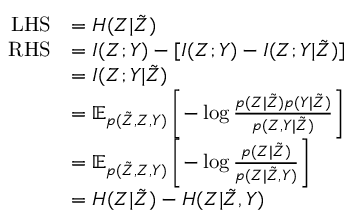<formula> <loc_0><loc_0><loc_500><loc_500>\begin{array} { r l } { L H S } & { = H ( Z | \tilde { Z } ) } \\ { R H S } & { = I ( Z ; Y ) - [ I ( Z ; Y ) - I ( Z ; Y | \tilde { Z } ) ] } \\ & { = I ( Z ; Y | \tilde { Z } ) } \\ & { = \mathbb { E } _ { p ( \tilde { Z } , Z , Y ) } \left [ - \log \frac { p ( Z | \tilde { Z } ) p ( Y | \tilde { Z } ) } { p ( Z , Y | \tilde { Z } ) } \right ] } \\ & { = \mathbb { E } _ { p ( \tilde { Z } , Z , Y ) } \left [ - \log \frac { p ( Z | \tilde { Z } ) } { p ( Z | \tilde { Z } , Y ) } \right ] } \\ & { = H ( Z | \tilde { Z } ) - H ( Z | \tilde { Z } , Y ) } \end{array}</formula> 